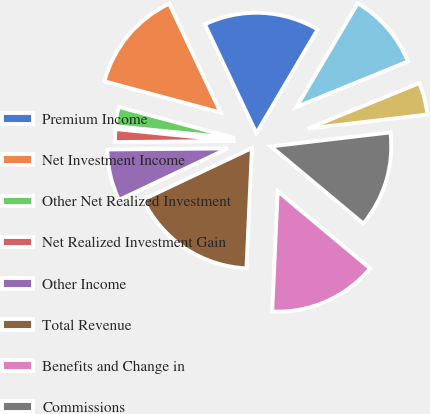Convert chart. <chart><loc_0><loc_0><loc_500><loc_500><pie_chart><fcel>Premium Income<fcel>Net Investment Income<fcel>Other Net Realized Investment<fcel>Net Realized Investment Gain<fcel>Other Income<fcel>Total Revenue<fcel>Benefits and Change in<fcel>Commissions<fcel>Interest and Debt Expense<fcel>Deferral of Acquisition Costs<nl><fcel>15.52%<fcel>13.79%<fcel>2.59%<fcel>1.72%<fcel>6.9%<fcel>17.24%<fcel>14.65%<fcel>12.93%<fcel>4.31%<fcel>10.34%<nl></chart> 